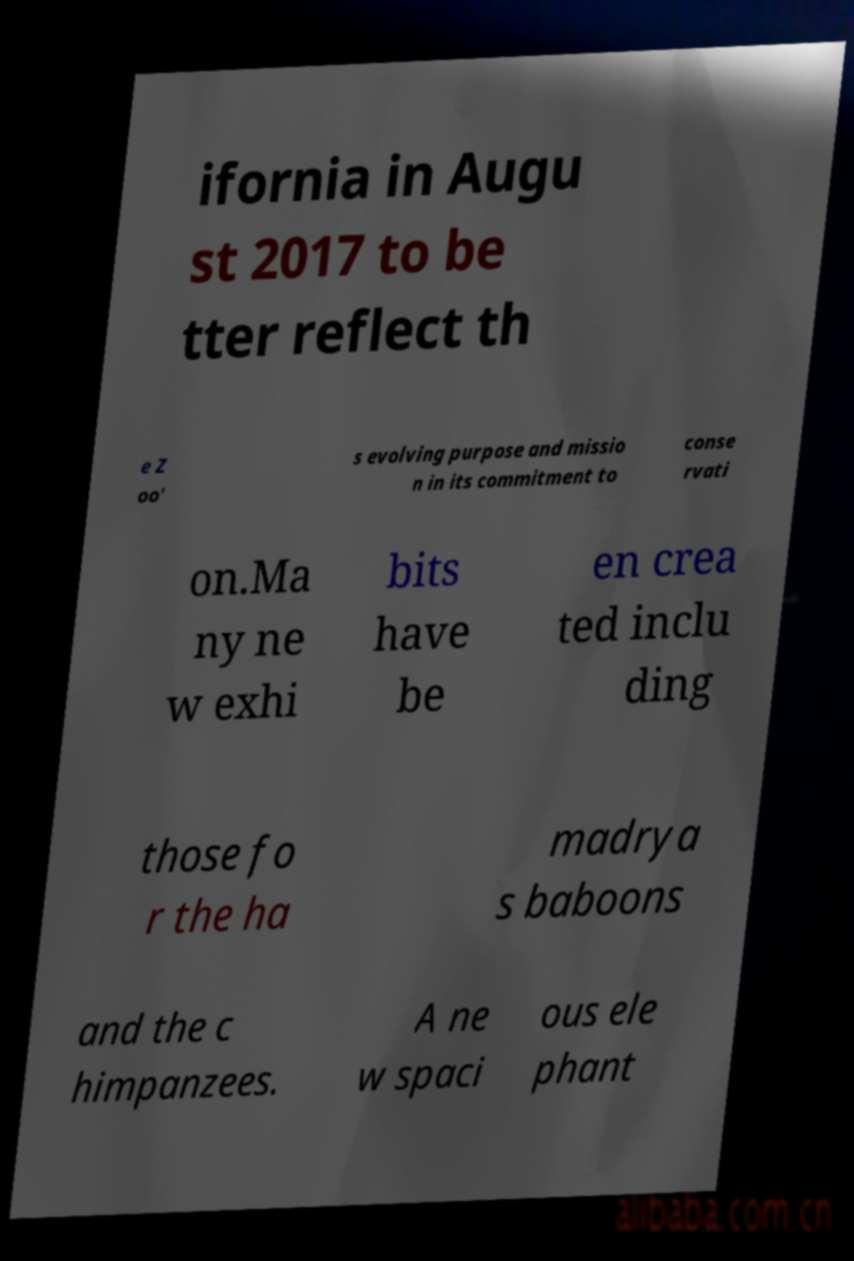There's text embedded in this image that I need extracted. Can you transcribe it verbatim? ifornia in Augu st 2017 to be tter reflect th e Z oo' s evolving purpose and missio n in its commitment to conse rvati on.Ma ny ne w exhi bits have be en crea ted inclu ding those fo r the ha madrya s baboons and the c himpanzees. A ne w spaci ous ele phant 